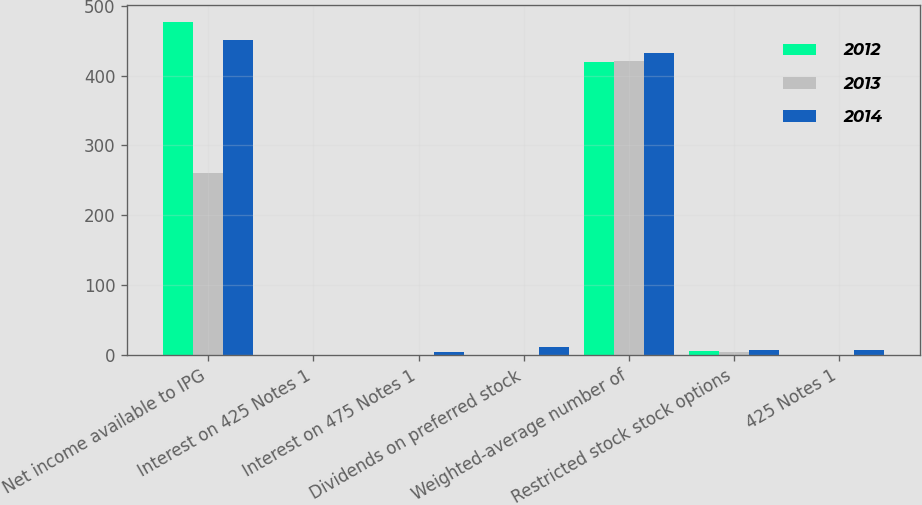Convert chart to OTSL. <chart><loc_0><loc_0><loc_500><loc_500><stacked_bar_chart><ecel><fcel>Net income available to IPG<fcel>Interest on 425 Notes 1<fcel>Interest on 475 Notes 1<fcel>Dividends on preferred stock<fcel>Weighted-average number of<fcel>Restricted stock stock options<fcel>425 Notes 1<nl><fcel>2012<fcel>477.1<fcel>0<fcel>0<fcel>0<fcel>419.2<fcel>6.2<fcel>0<nl><fcel>2013<fcel>260<fcel>0<fcel>0.8<fcel>0<fcel>421.1<fcel>5.2<fcel>0<nl><fcel>2014<fcel>451.1<fcel>0.3<fcel>4.1<fcel>11.6<fcel>432.5<fcel>7.2<fcel>7.9<nl></chart> 